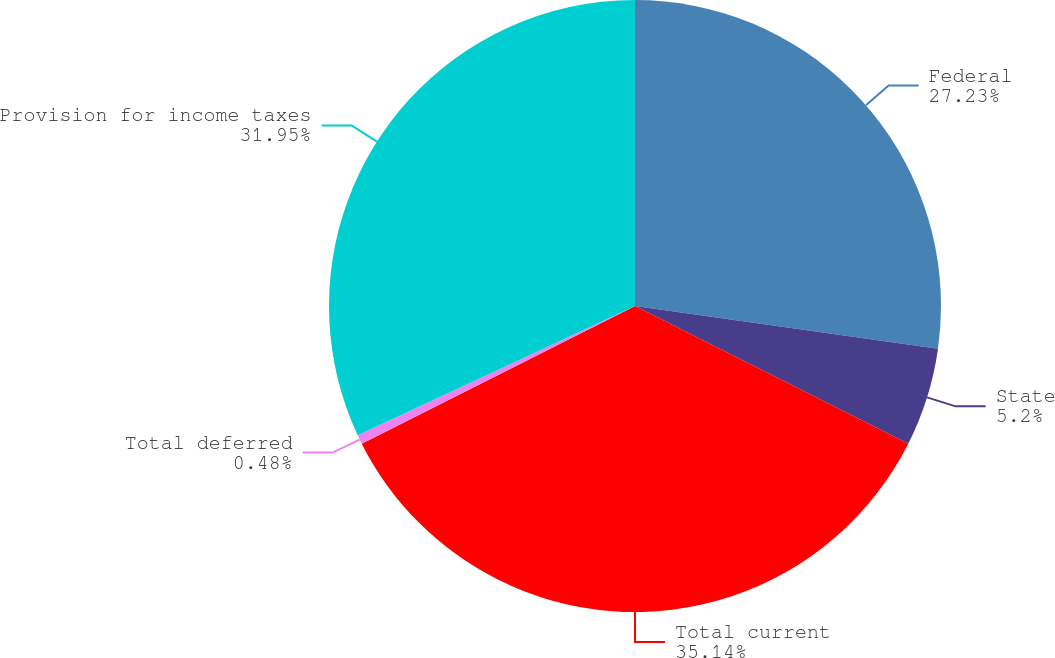<chart> <loc_0><loc_0><loc_500><loc_500><pie_chart><fcel>Federal<fcel>State<fcel>Total current<fcel>Total deferred<fcel>Provision for income taxes<nl><fcel>27.23%<fcel>5.2%<fcel>35.15%<fcel>0.48%<fcel>31.95%<nl></chart> 